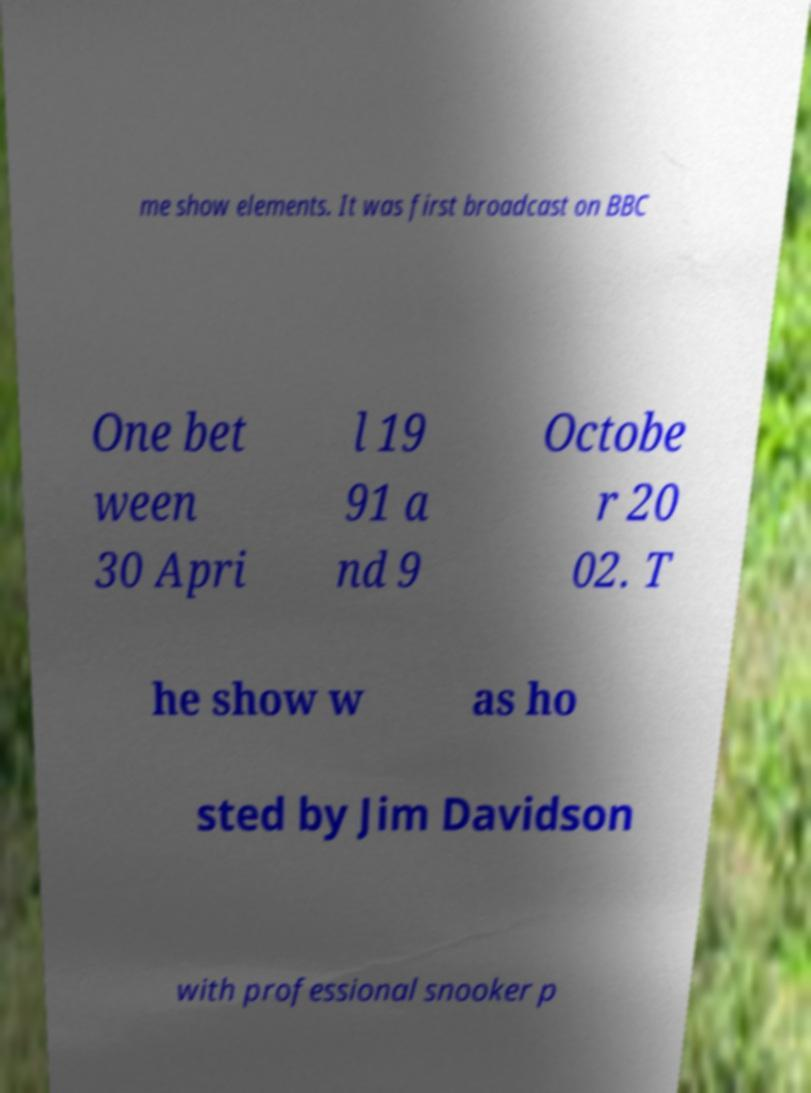There's text embedded in this image that I need extracted. Can you transcribe it verbatim? me show elements. It was first broadcast on BBC One bet ween 30 Apri l 19 91 a nd 9 Octobe r 20 02. T he show w as ho sted by Jim Davidson with professional snooker p 